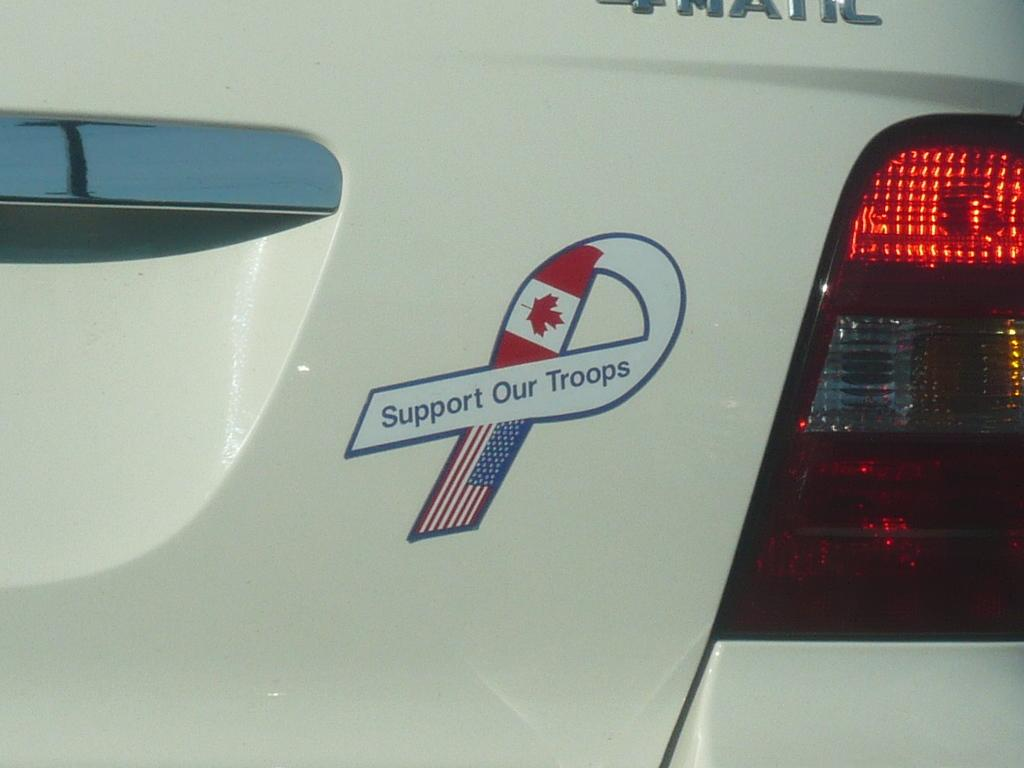What is the main subject of the image? The main subject of the image is a car. Are there any distinguishing features on the car? Yes, there is a logo and text visible on the car. Can you describe any specific parts of the car? There is a light on the car. What type of dirt can be seen on the car in the image? There is no dirt visible on the car in the image. Can you provide an example of a similar car to the one in the image? It is not possible to provide an example of a similar car based solely on the information in the image. 